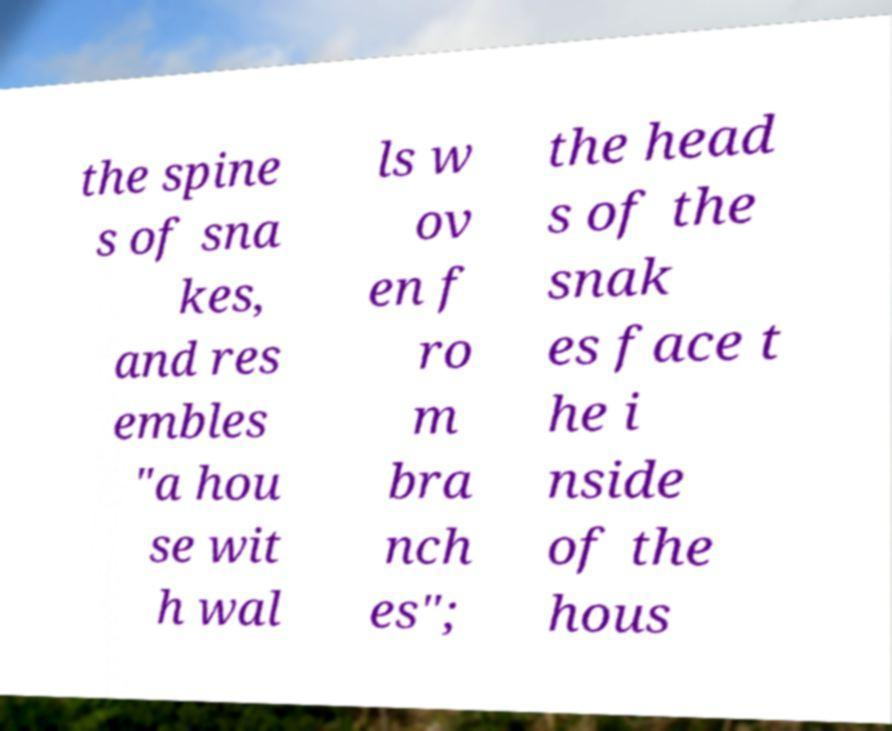Could you extract and type out the text from this image? the spine s of sna kes, and res embles "a hou se wit h wal ls w ov en f ro m bra nch es"; the head s of the snak es face t he i nside of the hous 